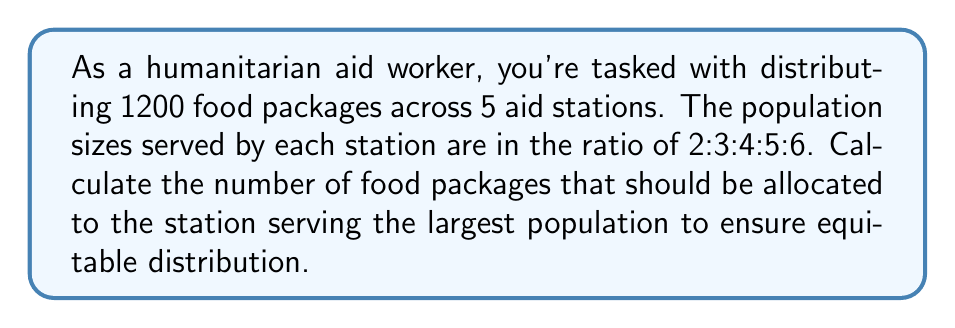Give your solution to this math problem. Let's approach this step-by-step:

1) First, let's define our variables:
   Let $x$ be the number of packages for the smallest population.

2) Given the ratio 2:3:4:5:6, we can express the packages for each station in terms of $x$:
   Station 1: $2x$
   Station 2: $3x$
   Station 3: $4x$
   Station 4: $5x$
   Station 5: $6x$

3) The total number of packages is 1200, so we can set up an equation:

   $2x + 3x + 4x + 5x + 6x = 1200$

4) Simplify the left side of the equation:

   $20x = 1200$

5) Solve for $x$:

   $x = \frac{1200}{20} = 60$

6) Now that we know $x$, we can calculate the number of packages for each station:
   Station 1: $2(60) = 120$
   Station 2: $3(60) = 180$
   Station 3: $4(60) = 240$
   Station 4: $5(60) = 300$
   Station 5: $6(60) = 360$

7) The question asks for the number of packages for the station serving the largest population, which is Station 5.
Answer: 360 packages 